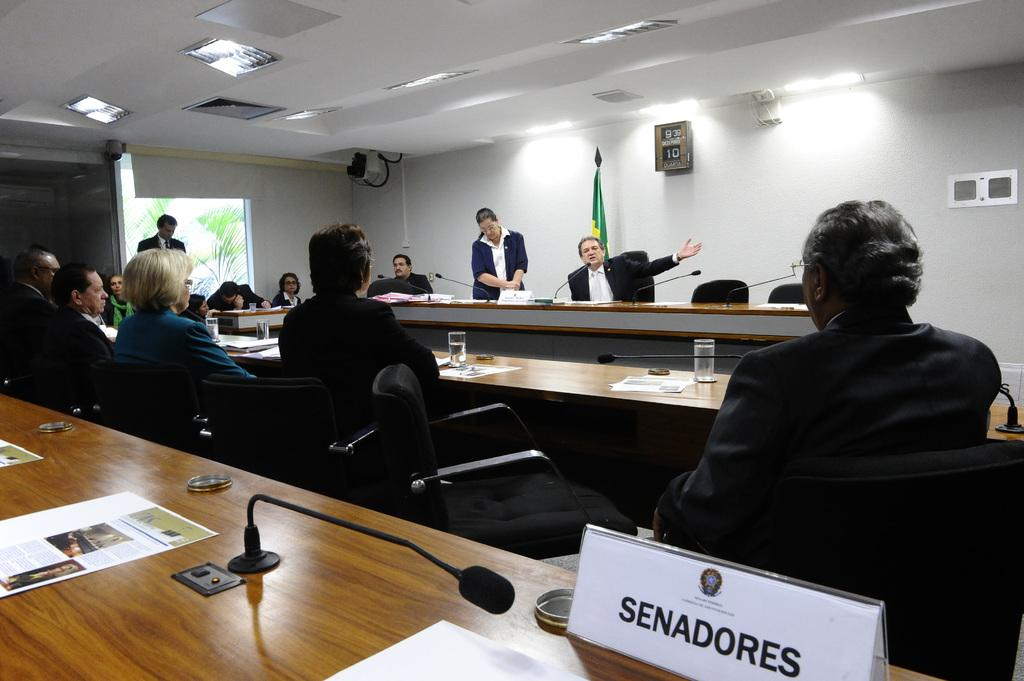<image>
Write a terse but informative summary of the picture. A man sits looking a speaker with a sign saying Senadores behind him. 